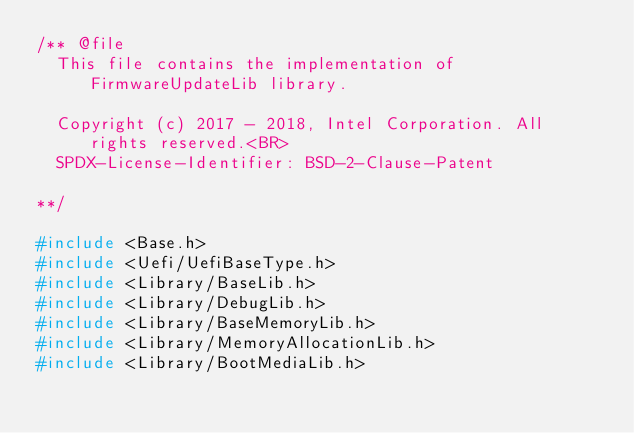Convert code to text. <code><loc_0><loc_0><loc_500><loc_500><_C_>/** @file
  This file contains the implementation of FirmwareUpdateLib library.

  Copyright (c) 2017 - 2018, Intel Corporation. All rights reserved.<BR>
  SPDX-License-Identifier: BSD-2-Clause-Patent

**/

#include <Base.h>
#include <Uefi/UefiBaseType.h>
#include <Library/BaseLib.h>
#include <Library/DebugLib.h>
#include <Library/BaseMemoryLib.h>
#include <Library/MemoryAllocationLib.h>
#include <Library/BootMediaLib.h></code> 